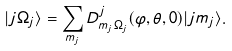Convert formula to latex. <formula><loc_0><loc_0><loc_500><loc_500>| j \Omega _ { j } \rangle = \sum _ { m _ { j } } D ^ { j } _ { m _ { j } \Omega _ { j } } ( \varphi , \theta , 0 ) | j m _ { j } \rangle .</formula> 